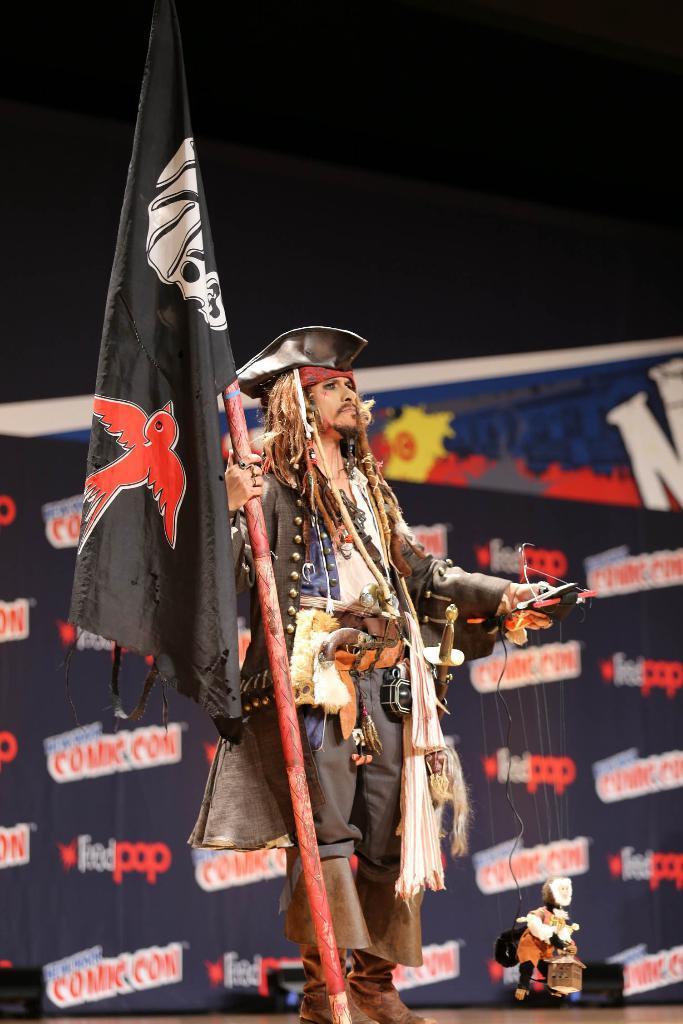Please provide a concise description of this image. In this image person is standing by holding the flag on one hand and on other hand there is some object. At the background there is a banner and there are three cameras on the surface of the floor. 